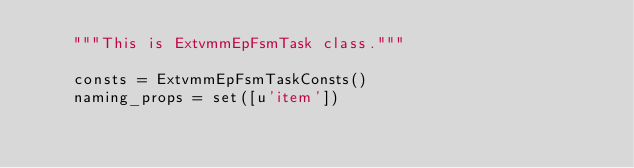<code> <loc_0><loc_0><loc_500><loc_500><_Python_>    """This is ExtvmmEpFsmTask class."""

    consts = ExtvmmEpFsmTaskConsts()
    naming_props = set([u'item'])
</code> 